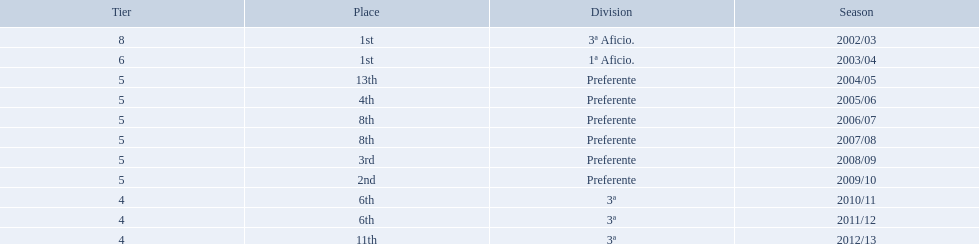Which seasons were played in tier four? 2010/11, 2011/12, 2012/13. Of these seasons, which resulted in 6th place? 2010/11, 2011/12. Which of the remaining happened last? 2011/12. 